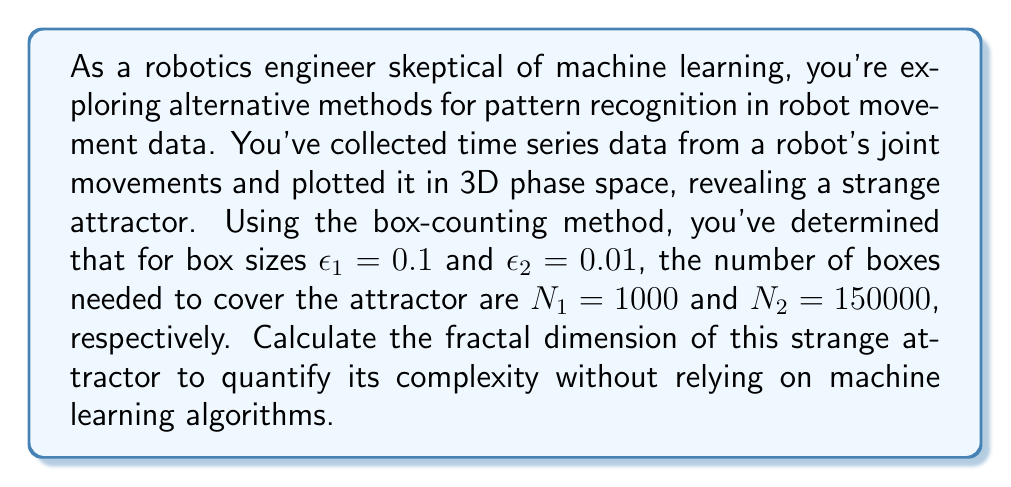Give your solution to this math problem. To determine the fractal dimension of the strange attractor using the box-counting method, we'll follow these steps:

1) The box-counting dimension $D$ is defined as:

   $$D = \lim_{\epsilon \to 0} \frac{\log N(\epsilon)}{\log(1/\epsilon)}$$

   where $N(\epsilon)$ is the number of boxes of size $\epsilon$ needed to cover the attractor.

2) For finite $\epsilon$ values, we can approximate this using:

   $$D \approx \frac{\log N(\epsilon_2) - \log N(\epsilon_1)}{\log(1/\epsilon_2) - \log(1/\epsilon_1)}$$

3) Let's substitute our known values:
   $\epsilon_1 = 0.1$, $\epsilon_2 = 0.01$
   $N(\epsilon_1) = N_1 = 1000$, $N(\epsilon_2) = N_2 = 150000$

4) Calculate the numerator:
   $$\log N(\epsilon_2) - \log N(\epsilon_1) = \log 150000 - \log 1000 = 5.17609 - 3 = 2.17609$$

5) Calculate the denominator:
   $$\log(1/\epsilon_2) - \log(1/\epsilon_1) = \log 100 - \log 10 = 2 - 1 = 1$$

6) Divide the results from steps 4 and 5:

   $$D \approx \frac{2.17609}{1} = 2.17609$$

This non-integer dimension between 2 and 3 is characteristic of strange attractors, indicating a fractal structure.
Answer: $2.17609$ 